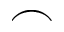Convert formula to latex. <formula><loc_0><loc_0><loc_500><loc_500>\frown</formula> 